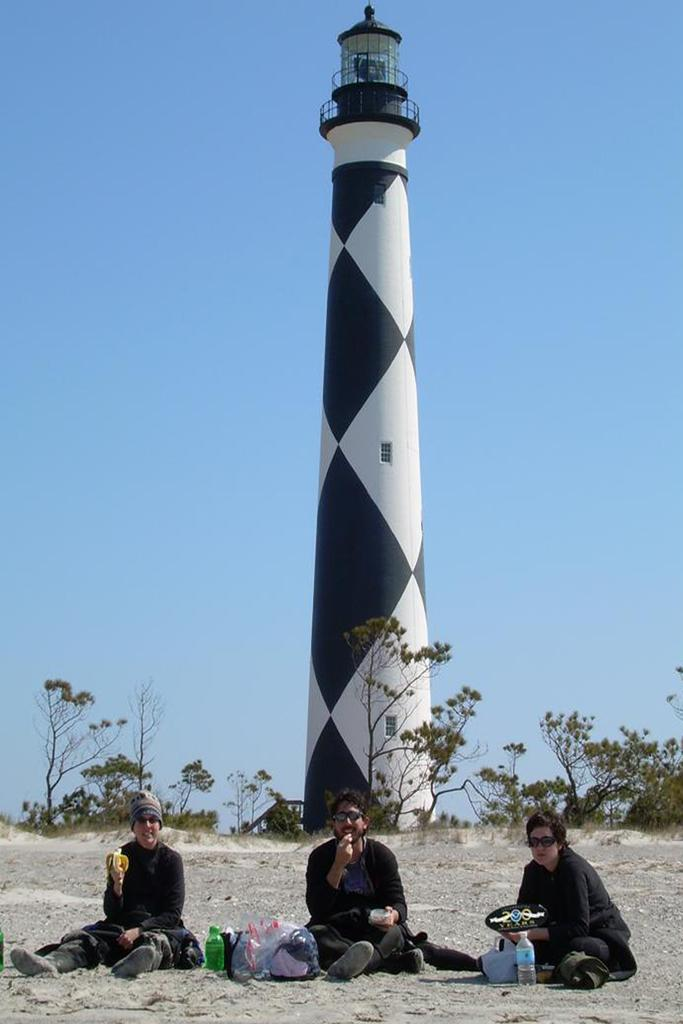How many people are sitting on the ground in the image? There are three persons sitting on the ground in the image. What else can be seen on the ground besides the people? There are bottles and bags on the ground. What can be seen in the background of the image? There are plants, a lighthouse, and the sky visible in the background of the image. What type of net is being used to catch the honey in the image? There is no net or honey present in the image; it features three persons sitting on the ground with bottles and bags, along with a background that includes plants, a lighthouse, and the sky. 